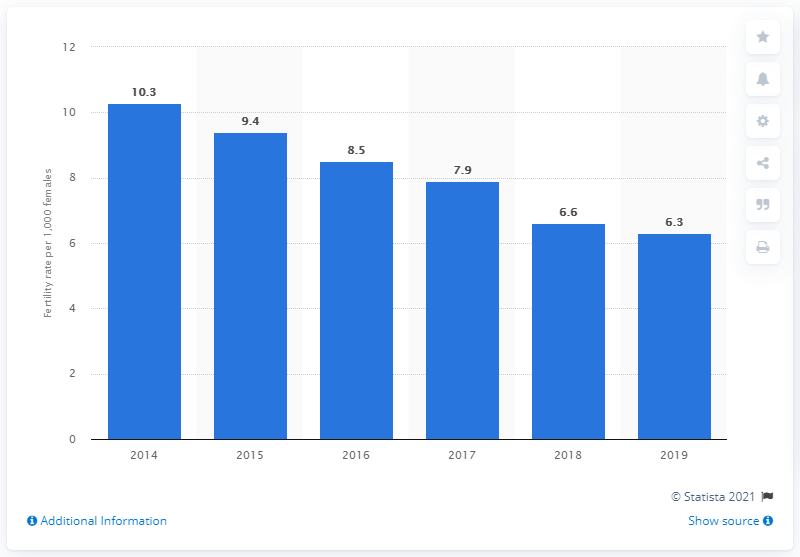Give some essential details in this illustration. In 2019, the fertility rate of females aged 15 to 19 years per 1,000 females in Canada was 6.3. 